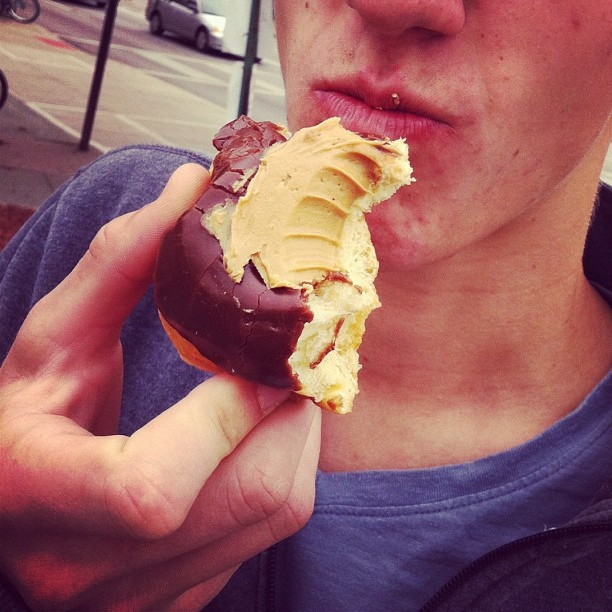Describe the objects in this image and their specific colors. I can see people in black, brown, tan, maroon, and purple tones, donut in black, tan, maroon, and brown tones, and car in black, purple, beige, and lightgray tones in this image. 